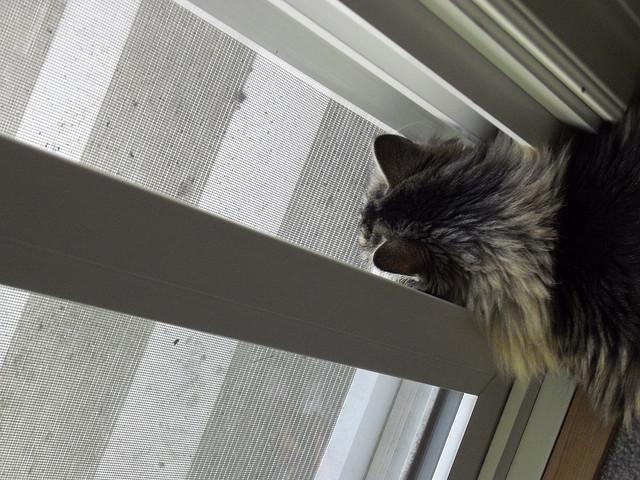How many people are holding a green frisbee?
Give a very brief answer. 0. 